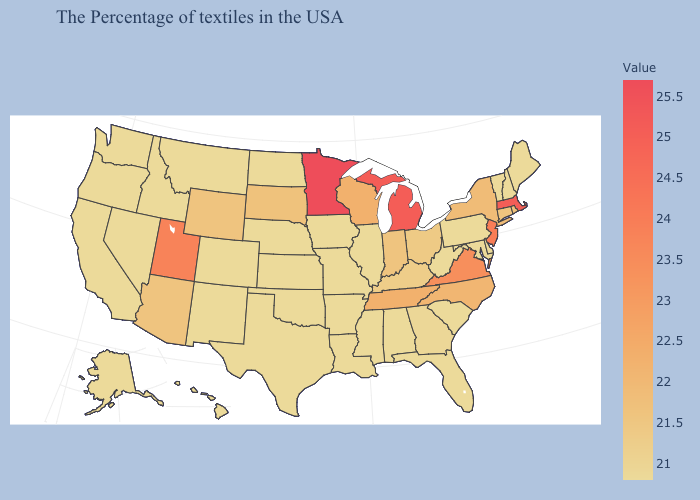Is the legend a continuous bar?
Concise answer only. Yes. Does Maine have the lowest value in the Northeast?
Short answer required. Yes. Among the states that border Rhode Island , does Massachusetts have the lowest value?
Write a very short answer. No. 